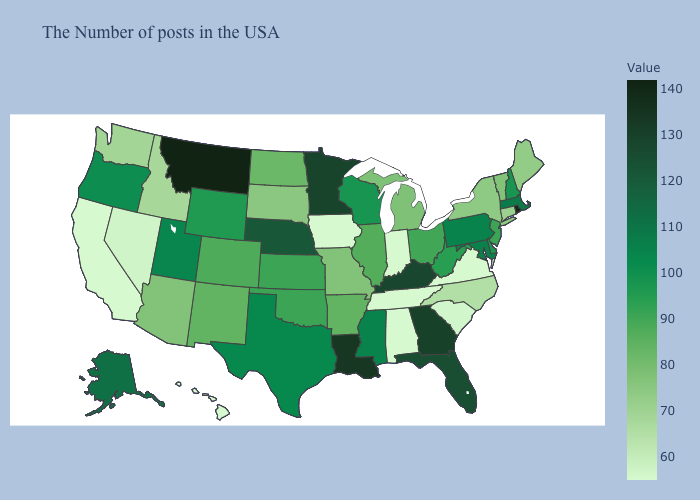Among the states that border New York , which have the lowest value?
Answer briefly. Connecticut. Does Louisiana have a higher value than Missouri?
Give a very brief answer. Yes. Among the states that border Texas , does Louisiana have the highest value?
Short answer required. Yes. Does Illinois have the lowest value in the USA?
Short answer required. No. Which states hav the highest value in the West?
Concise answer only. Montana. 